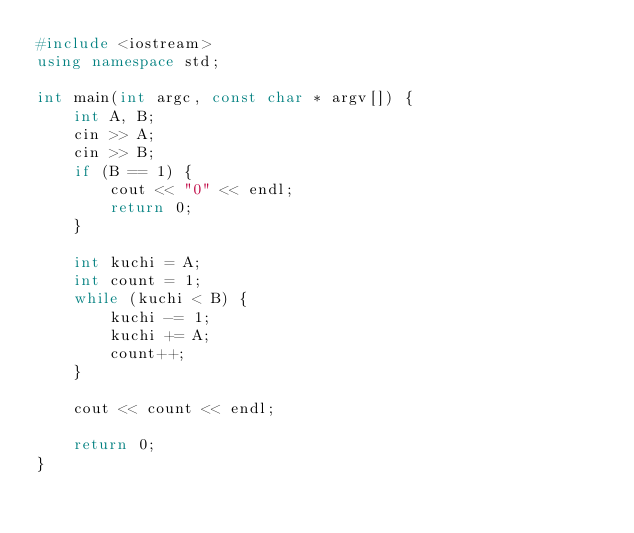Convert code to text. <code><loc_0><loc_0><loc_500><loc_500><_C++_>#include <iostream>
using namespace std;

int main(int argc, const char * argv[]) {
    int A, B;
    cin >> A;
    cin >> B;
    if (B == 1) {
        cout << "0" << endl;
        return 0;
    }
    
    int kuchi = A;
    int count = 1;
    while (kuchi < B) {
        kuchi -= 1;
        kuchi += A;
        count++;
    }
    
    cout << count << endl;
    
    return 0;
}
</code> 